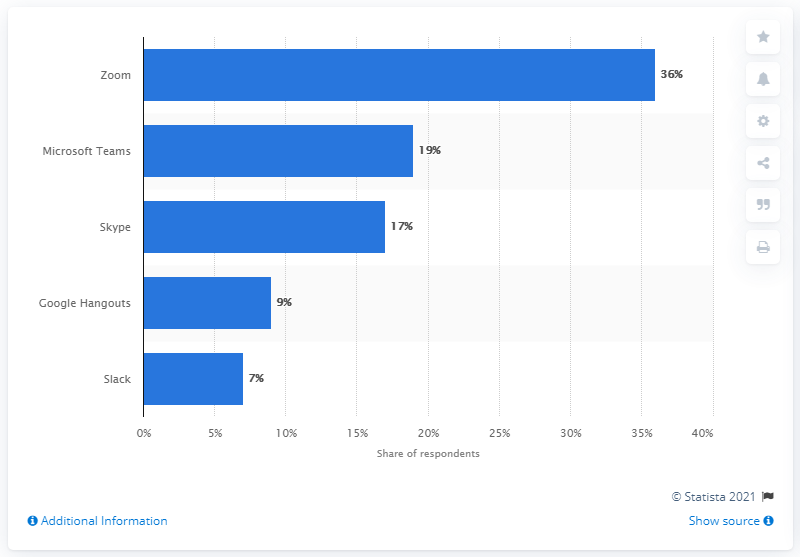Give some essential details in this illustration. Skype is an online collaboration tool that enables users to communicate and collaborate remotely through voice, video, and text conversations. 